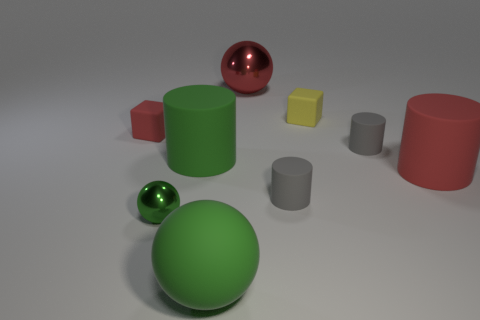What is the shape of the tiny yellow thing that is the same material as the large green cylinder?
Provide a short and direct response. Cube. Is there anything else that is the same color as the large metal object?
Give a very brief answer. Yes. What number of balls are behind the rubber cube behind the small matte block that is to the left of the red ball?
Your answer should be very brief. 1. How many purple objects are tiny matte objects or matte things?
Provide a short and direct response. 0. Does the green cylinder have the same size as the cube that is in front of the yellow matte thing?
Ensure brevity in your answer.  No. What material is the tiny thing that is the same shape as the large red metal thing?
Offer a terse response. Metal. How many other objects are the same size as the red sphere?
Your response must be concise. 3. There is a gray thing that is in front of the small thing on the right side of the matte thing that is behind the red matte block; what is its shape?
Make the answer very short. Cylinder. There is a red object that is in front of the red metal ball and on the right side of the small shiny object; what shape is it?
Offer a terse response. Cylinder. How many things are tiny green things or tiny cylinders left of the yellow rubber thing?
Keep it short and to the point. 2. 